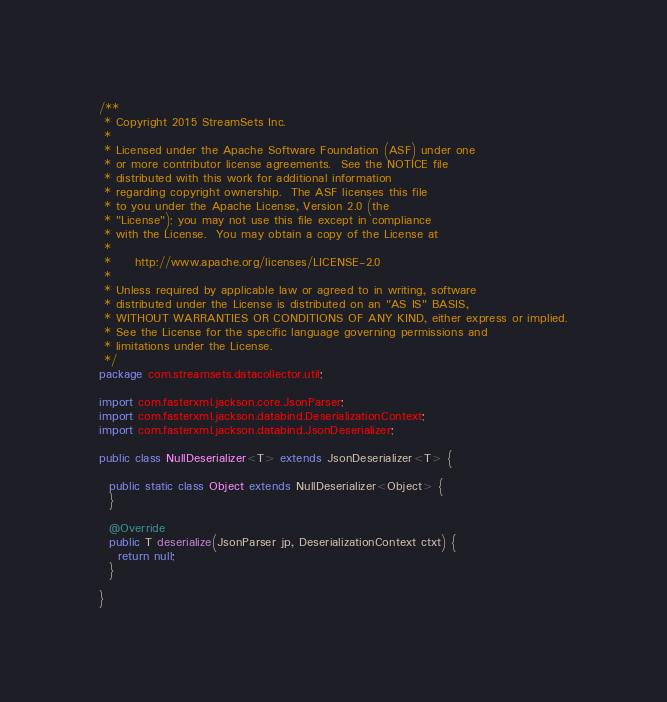<code> <loc_0><loc_0><loc_500><loc_500><_Java_>/**
 * Copyright 2015 StreamSets Inc.
 *
 * Licensed under the Apache Software Foundation (ASF) under one
 * or more contributor license agreements.  See the NOTICE file
 * distributed with this work for additional information
 * regarding copyright ownership.  The ASF licenses this file
 * to you under the Apache License, Version 2.0 (the
 * "License"); you may not use this file except in compliance
 * with the License.  You may obtain a copy of the License at
 *
 *     http://www.apache.org/licenses/LICENSE-2.0
 *
 * Unless required by applicable law or agreed to in writing, software
 * distributed under the License is distributed on an "AS IS" BASIS,
 * WITHOUT WARRANTIES OR CONDITIONS OF ANY KIND, either express or implied.
 * See the License for the specific language governing permissions and
 * limitations under the License.
 */
package com.streamsets.datacollector.util;

import com.fasterxml.jackson.core.JsonParser;
import com.fasterxml.jackson.databind.DeserializationContext;
import com.fasterxml.jackson.databind.JsonDeserializer;

public class NullDeserializer<T> extends JsonDeserializer<T> {

  public static class Object extends NullDeserializer<Object> {
  }

  @Override
  public T deserialize(JsonParser jp, DeserializationContext ctxt) {
    return null;
  }

}
</code> 